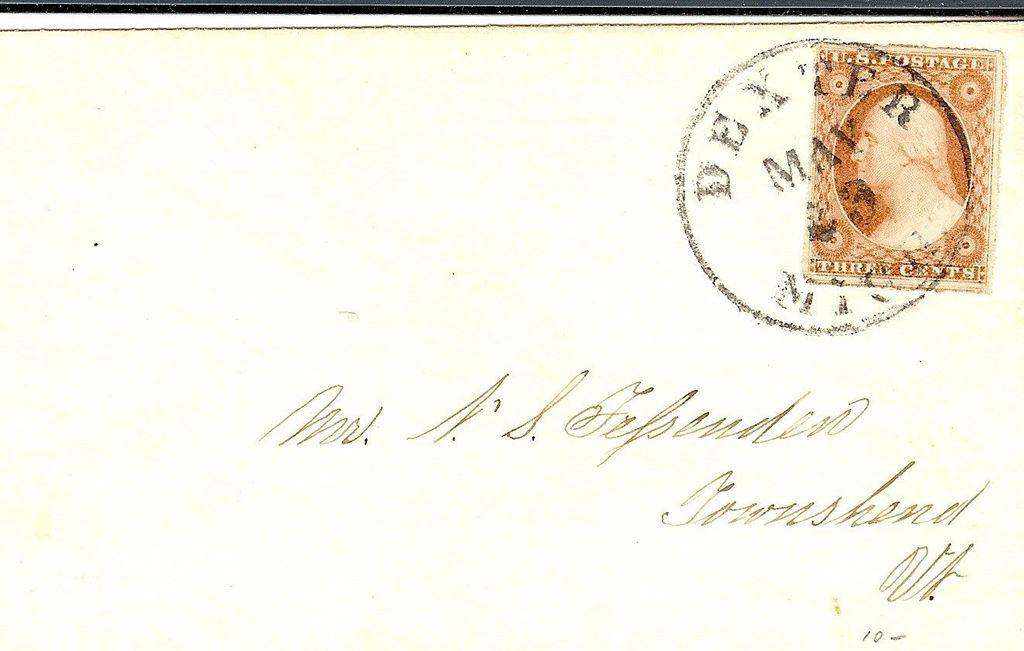<image>
Share a concise interpretation of the image provided. An old letter was stamped by the post office in May. 